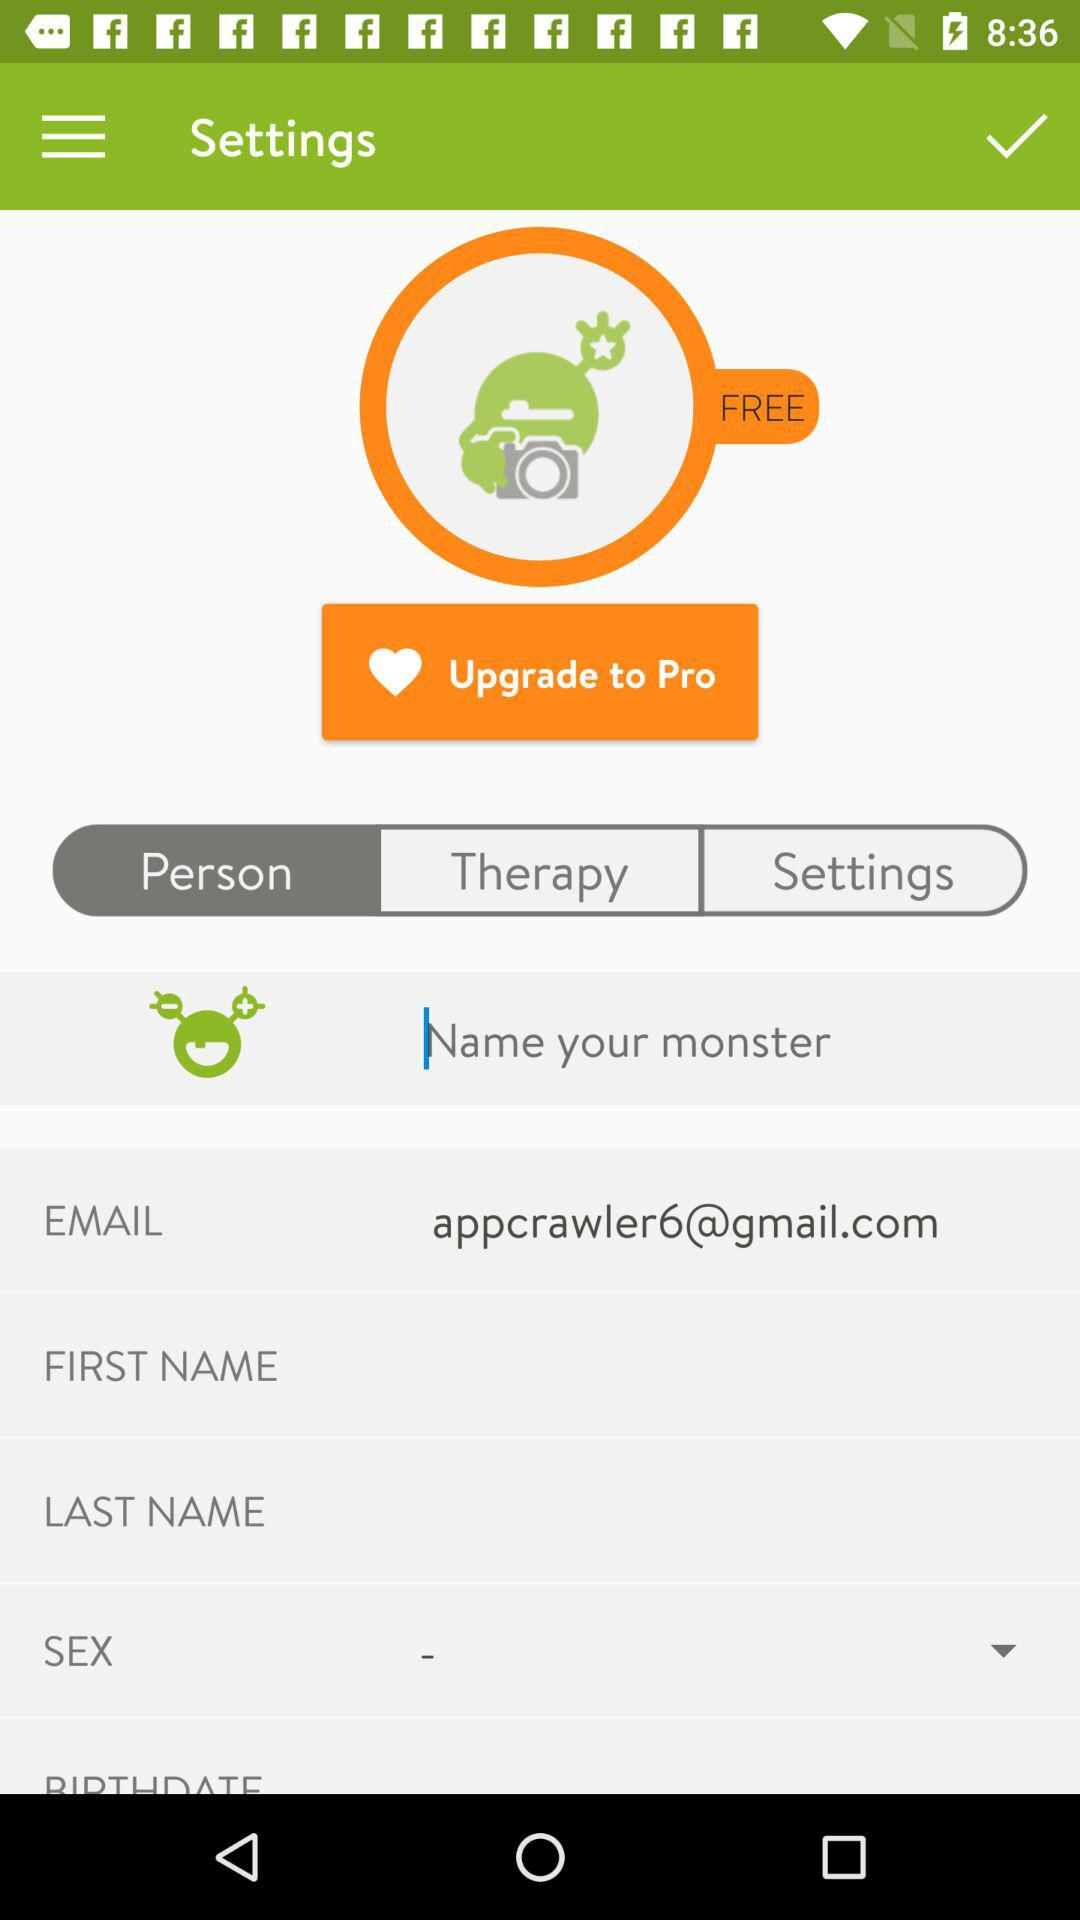What is the email address? The email address is appcrawler6@gmail.com. 